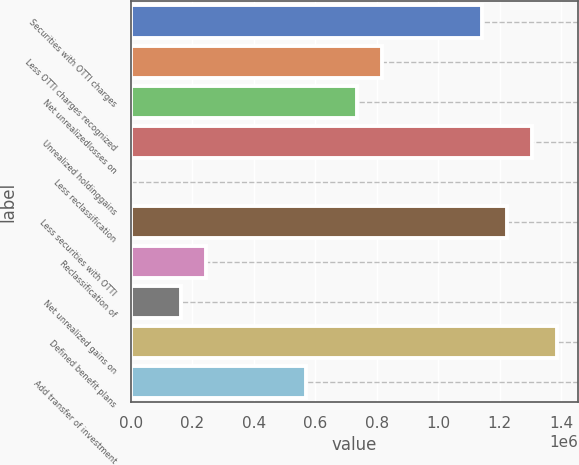Convert chart. <chart><loc_0><loc_0><loc_500><loc_500><bar_chart><fcel>Securities with OTTI charges<fcel>Less OTTI charges recognized<fcel>Net unrealizedlosses on<fcel>Unrealized holdinggains<fcel>Less reclassification<fcel>Less securities with OTTI<fcel>Reclassification of<fcel>Net unrealized gains on<fcel>Defined benefit plans<fcel>Add transfer of investment<nl><fcel>1.14237e+06<fcel>816042<fcel>734460<fcel>1.30554e+06<fcel>219<fcel>1.22395e+06<fcel>244966<fcel>163384<fcel>1.38712e+06<fcel>571295<nl></chart> 